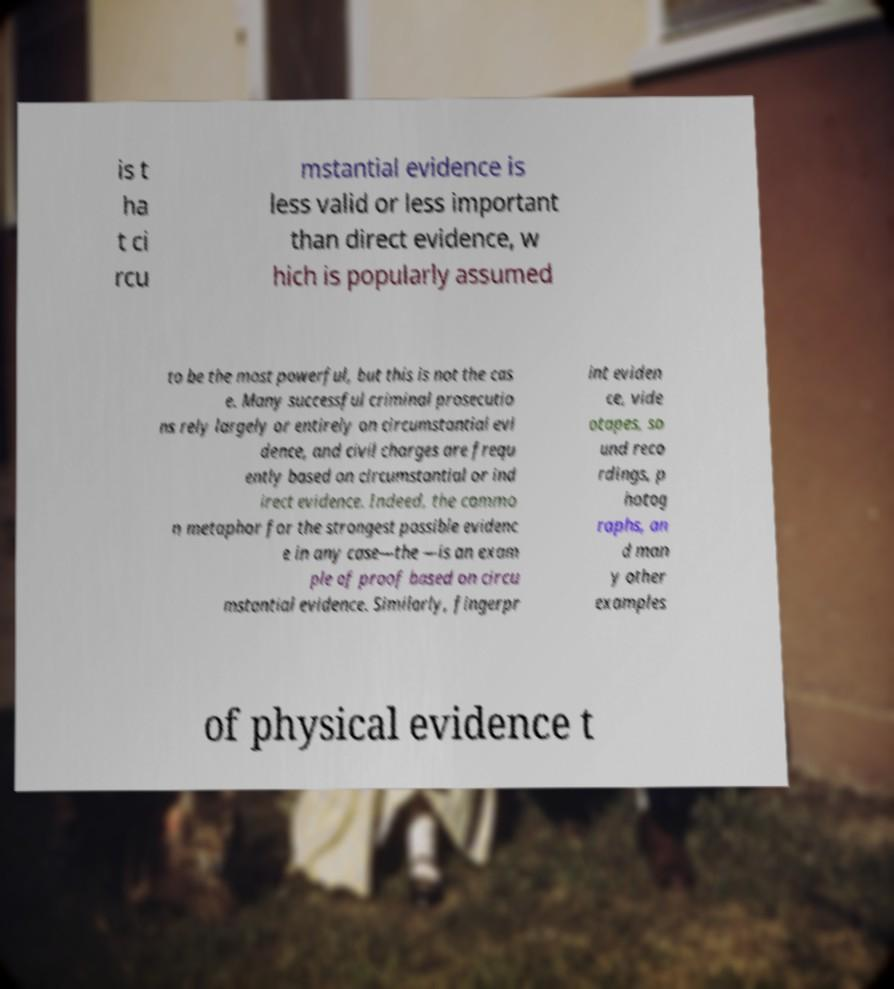Can you read and provide the text displayed in the image?This photo seems to have some interesting text. Can you extract and type it out for me? is t ha t ci rcu mstantial evidence is less valid or less important than direct evidence, w hich is popularly assumed to be the most powerful, but this is not the cas e. Many successful criminal prosecutio ns rely largely or entirely on circumstantial evi dence, and civil charges are frequ ently based on circumstantial or ind irect evidence. Indeed, the commo n metaphor for the strongest possible evidenc e in any case—the —is an exam ple of proof based on circu mstantial evidence. Similarly, fingerpr int eviden ce, vide otapes, so und reco rdings, p hotog raphs, an d man y other examples of physical evidence t 